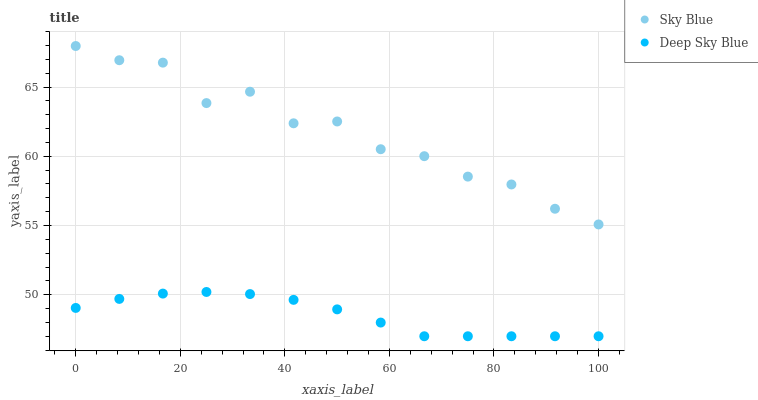Does Deep Sky Blue have the minimum area under the curve?
Answer yes or no. Yes. Does Sky Blue have the maximum area under the curve?
Answer yes or no. Yes. Does Deep Sky Blue have the maximum area under the curve?
Answer yes or no. No. Is Deep Sky Blue the smoothest?
Answer yes or no. Yes. Is Sky Blue the roughest?
Answer yes or no. Yes. Is Deep Sky Blue the roughest?
Answer yes or no. No. Does Deep Sky Blue have the lowest value?
Answer yes or no. Yes. Does Sky Blue have the highest value?
Answer yes or no. Yes. Does Deep Sky Blue have the highest value?
Answer yes or no. No. Is Deep Sky Blue less than Sky Blue?
Answer yes or no. Yes. Is Sky Blue greater than Deep Sky Blue?
Answer yes or no. Yes. Does Deep Sky Blue intersect Sky Blue?
Answer yes or no. No. 